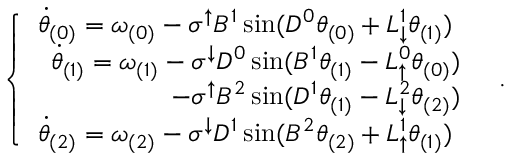<formula> <loc_0><loc_0><loc_500><loc_500>\begin{array} { r } { \left \{ \begin{array} { l l } { \ D o t { \theta } _ { ( 0 ) } = \omega _ { ( 0 ) } - \sigma ^ { \uparrow } B ^ { 1 } \sin ( D ^ { 0 } \theta _ { ( 0 ) } + L _ { \downarrow } ^ { 1 } \theta _ { ( 1 ) } ) } \\ { \begin{array} { r } { \ D o t { \theta } _ { ( 1 ) } = \omega _ { ( 1 ) } - \sigma ^ { \downarrow } D ^ { 0 } \sin ( B ^ { 1 } \theta _ { ( 1 ) } - L _ { \uparrow } ^ { 0 } \theta _ { ( 0 ) } ) } \\ { - \sigma ^ { \uparrow } B ^ { 2 } \sin ( D ^ { 1 } \theta _ { ( 1 ) } - L _ { \downarrow } ^ { 2 } \theta _ { ( 2 ) } ) } \end{array} } \\ { \ D o t { \theta } _ { ( 2 ) } = \omega _ { ( 2 ) } - \sigma ^ { \downarrow } D ^ { 1 } \sin ( B ^ { 2 } \theta _ { ( 2 ) } + L _ { \uparrow } ^ { 1 } \theta _ { ( 1 ) } ) } \end{array} \, . } \end{array}</formula> 